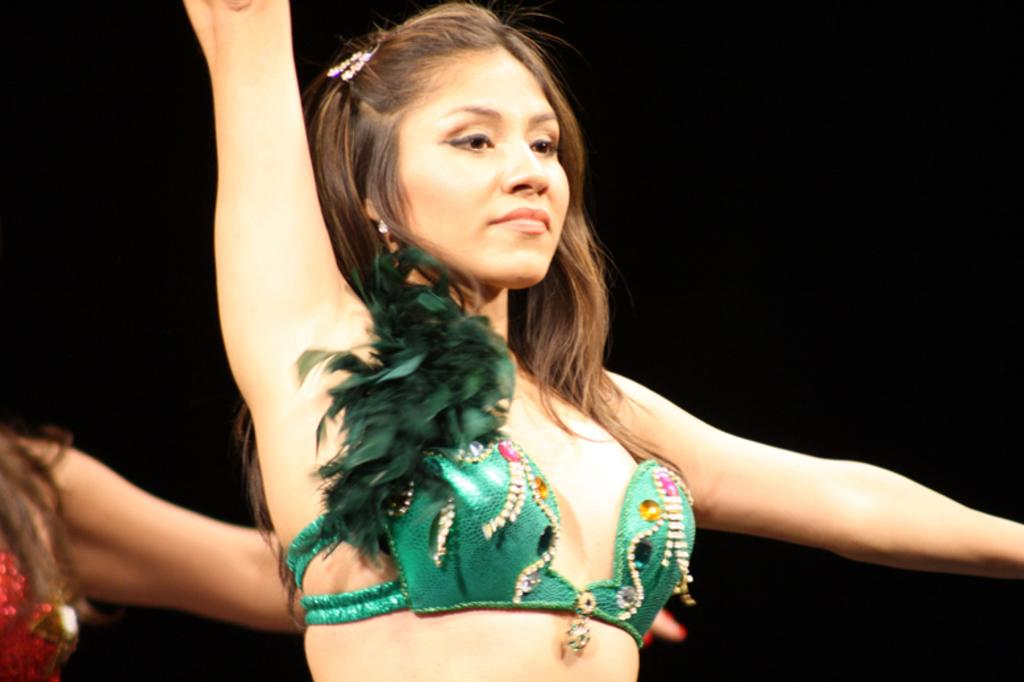Who or what is the main subject in the image? There is a person in the image. What can be observed about the background of the image? The background of the image is dark. Can you describe any specific details about the person's hand in the image? There is a hand visible in the bottom left of the image. What decision does the person make in the image? There is no indication of a decision being made in the image. 